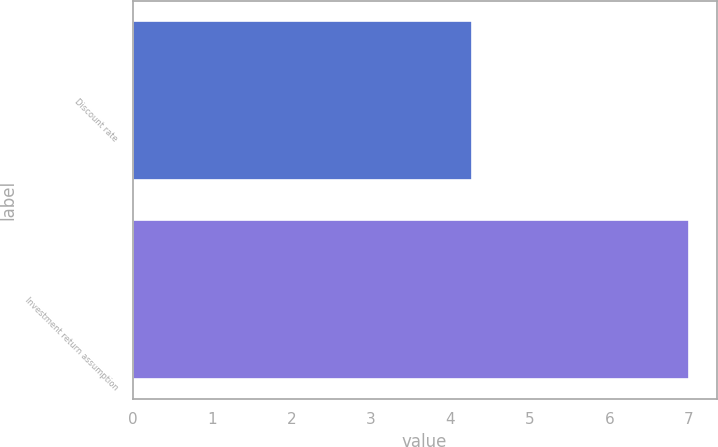Convert chart. <chart><loc_0><loc_0><loc_500><loc_500><bar_chart><fcel>Discount rate<fcel>Investment return assumption<nl><fcel>4.27<fcel>7<nl></chart> 